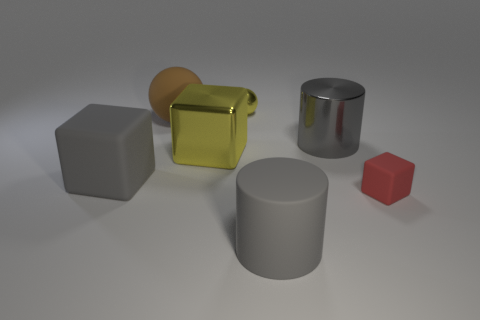Add 1 red cubes. How many objects exist? 8 Subtract all cylinders. How many objects are left? 5 Subtract 0 yellow cylinders. How many objects are left? 7 Subtract all tiny brown shiny spheres. Subtract all big gray blocks. How many objects are left? 6 Add 5 yellow shiny spheres. How many yellow shiny spheres are left? 6 Add 3 big gray matte balls. How many big gray matte balls exist? 3 